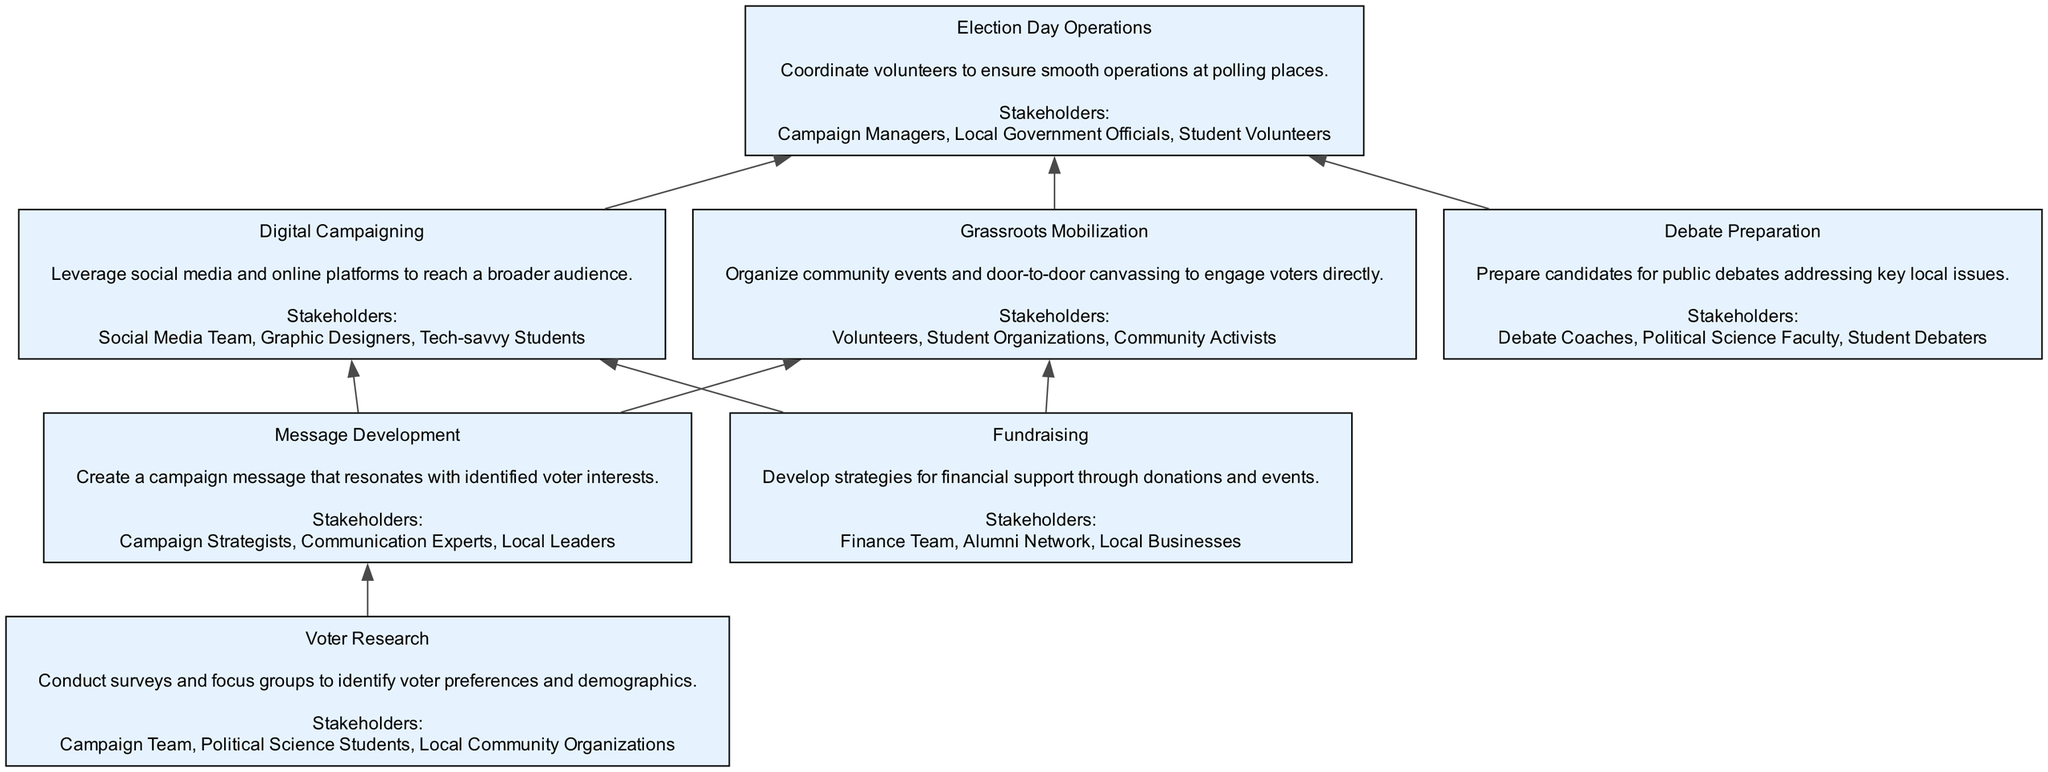What is the first step in the diagram? The first step in the diagram is "Voter Research," which is the starting node before all other steps in the flow.
Answer: Voter Research How many stakeholders are involved in "Fundraising"? The "Fundraising" step includes three stakeholders: the Finance Team, Alumni Network, and Local Businesses.
Answer: 3 Which two steps are directly connected to "Message Development"? The "Message Development" step is directly connected to "Grassroots Mobilization" and "Digital Campaigning," indicating it leads to both these actions.
Answer: Grassroots Mobilization, Digital Campaigning What is the last step before "Election Day Operations"? The last step before "Election Day Operations" is either "Grassroots Mobilization" or "Digital Campaigning," both of which funnel into the election day operations.
Answer: Grassroots Mobilization, Digital Campaigning Who participates in "Debate Preparation"? The stakeholders involved in "Debate Preparation" include Debate Coaches, Political Science Faculty, and Student Debaters, indicating their collective role in this step.
Answer: Debate Coaches, Political Science Faculty, Student Debaters How many edges lead to "Election Day Operations"? There are four edges leading to "Election Day Operations": from "Grassroots Mobilization," "Digital Campaigning," and "Debate Preparation," indicating various paths leading into this crucial operational stage.
Answer: 4 What do the stakeholders in "Digital Campaigning" contribute? The stakeholders in "Digital Campaigning," which include the Social Media Team, Graphic Designers, and Tech-savvy Students, contribute by leveraging online platforms for campaign outreach.
Answer: Social Media Team, Graphic Designers, Tech-savvy Students Which step involves local community engagement through events? The step that involves local community engagement through events is "Grassroots Mobilization," as it focuses on organizing community events and canvassing.
Answer: Grassroots Mobilization 